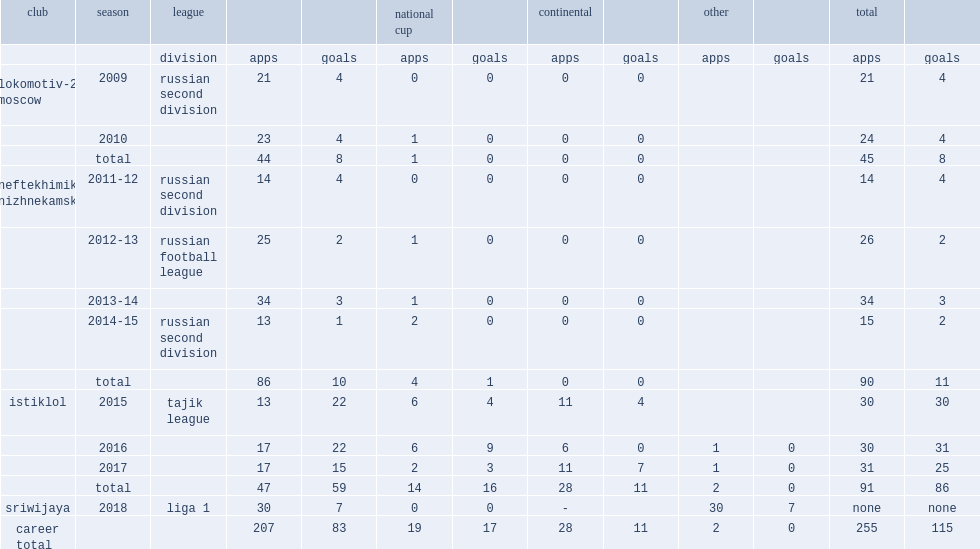In the 2015 season, which league did dzhalilov join fc istiklol? Tajik league. 